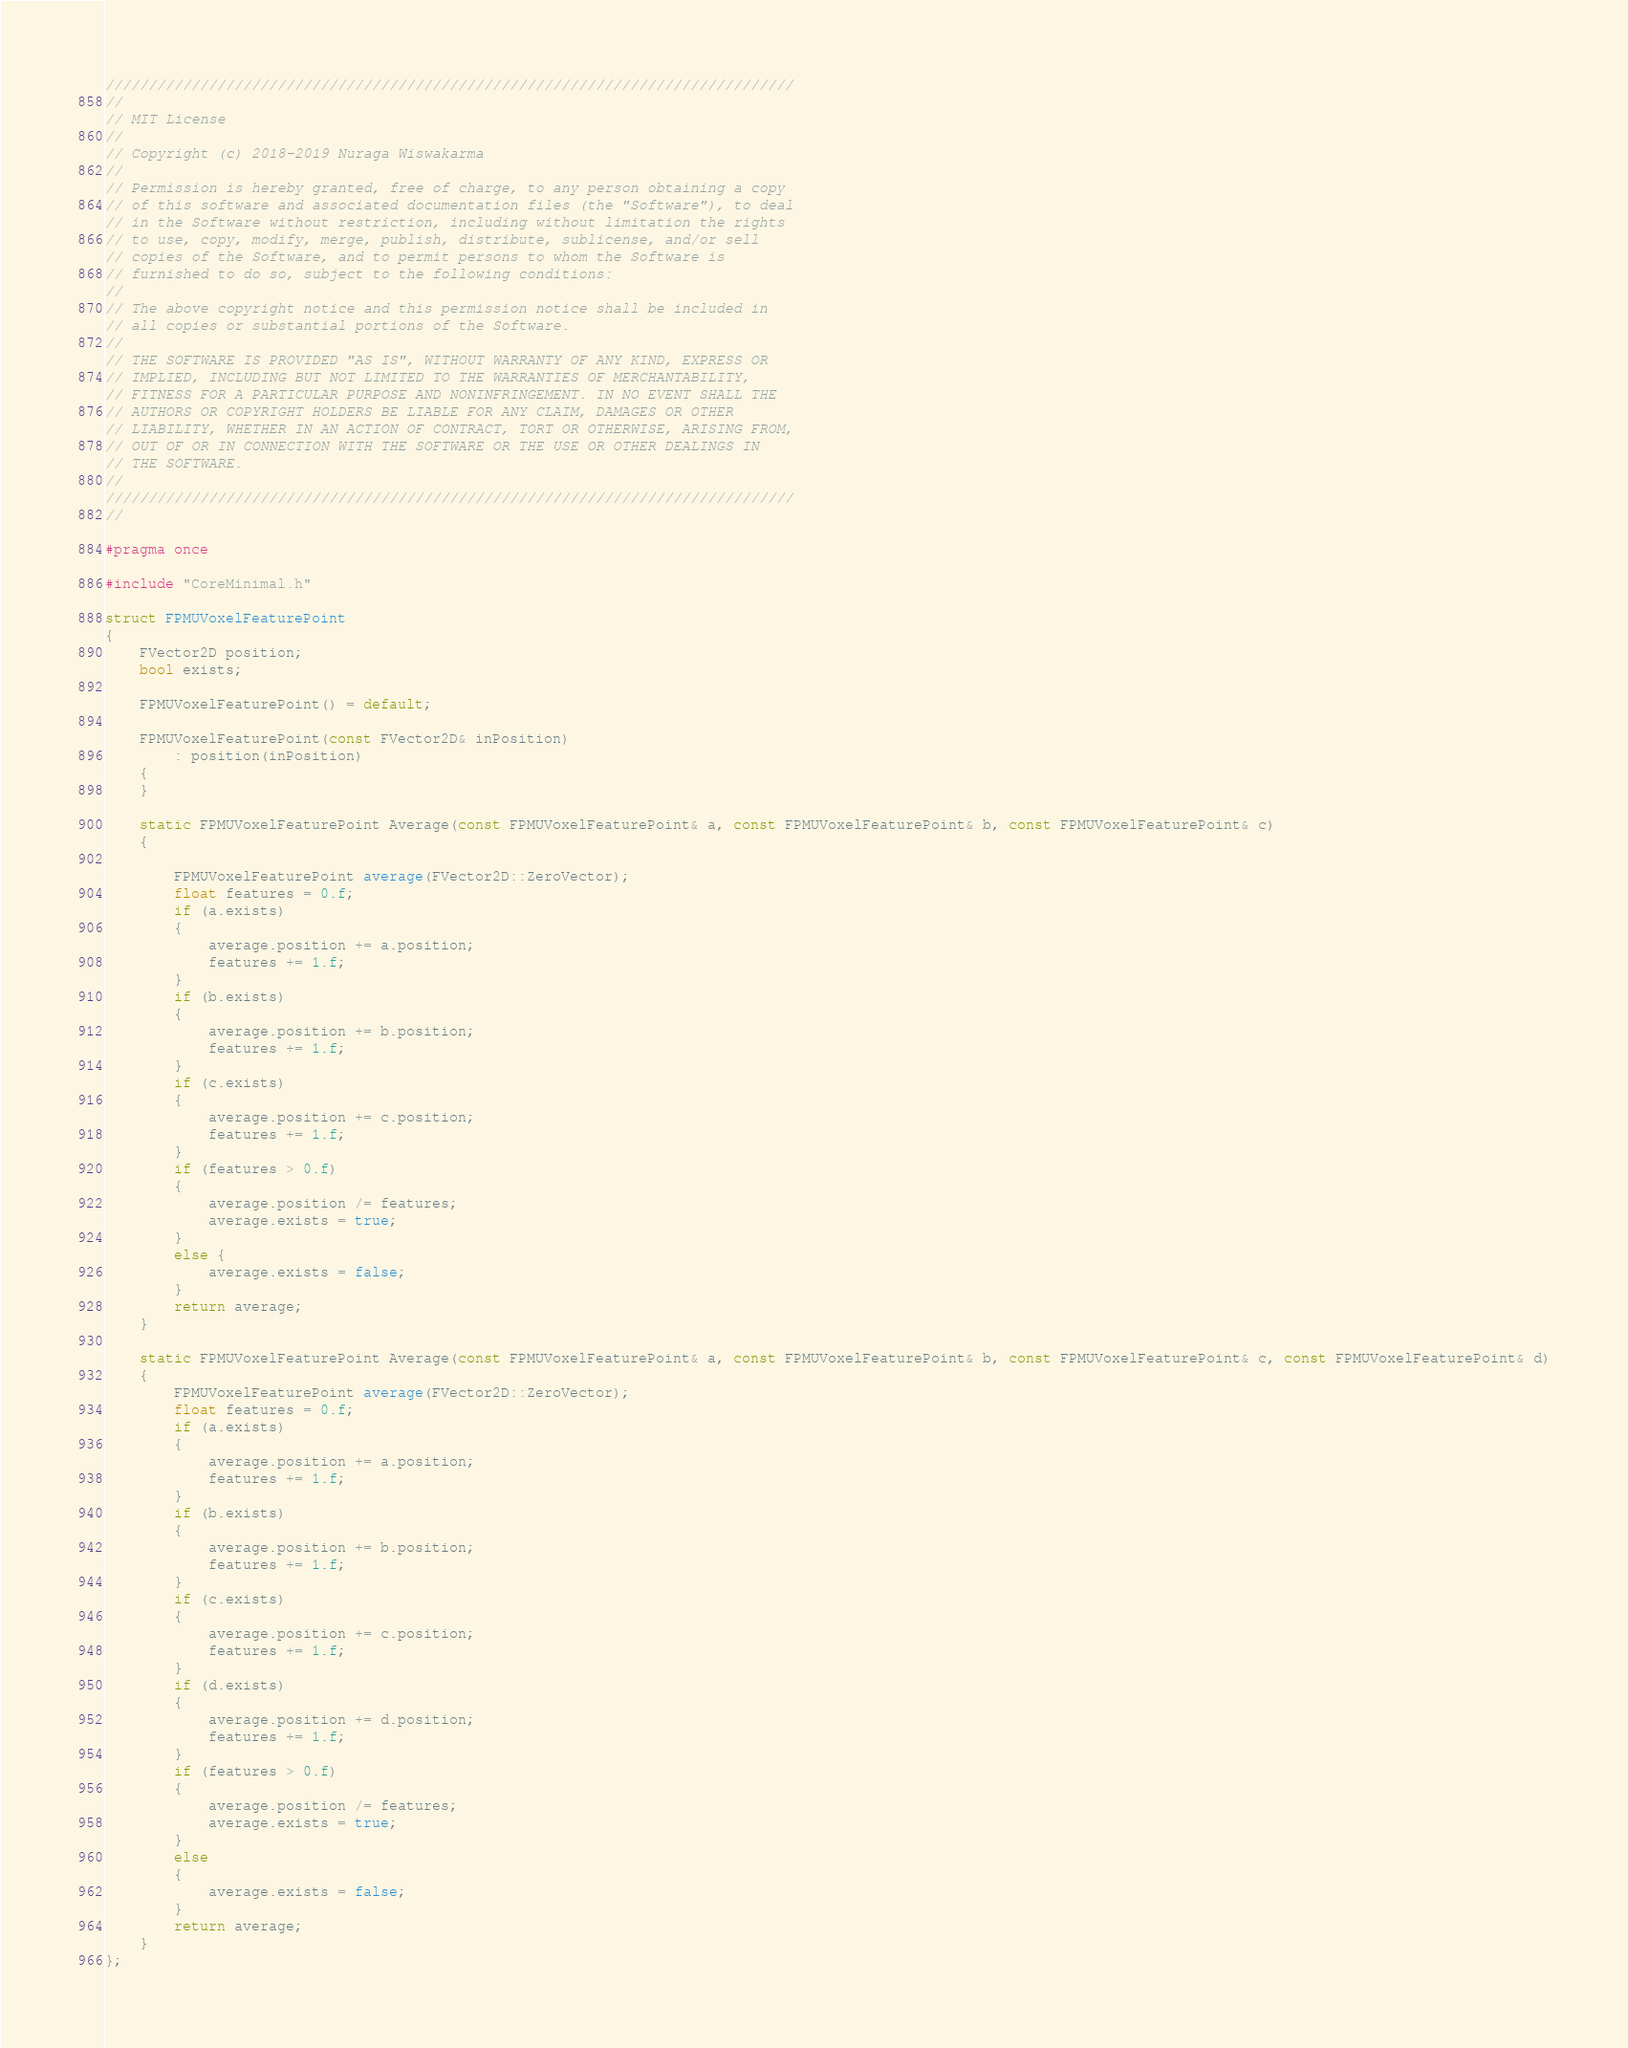<code> <loc_0><loc_0><loc_500><loc_500><_C_>////////////////////////////////////////////////////////////////////////////////
//
// MIT License
// 
// Copyright (c) 2018-2019 Nuraga Wiswakarma
// 
// Permission is hereby granted, free of charge, to any person obtaining a copy
// of this software and associated documentation files (the "Software"), to deal
// in the Software without restriction, including without limitation the rights
// to use, copy, modify, merge, publish, distribute, sublicense, and/or sell
// copies of the Software, and to permit persons to whom the Software is
// furnished to do so, subject to the following conditions:
// 
// The above copyright notice and this permission notice shall be included in
// all copies or substantial portions of the Software.
// 
// THE SOFTWARE IS PROVIDED "AS IS", WITHOUT WARRANTY OF ANY KIND, EXPRESS OR
// IMPLIED, INCLUDING BUT NOT LIMITED TO THE WARRANTIES OF MERCHANTABILITY,
// FITNESS FOR A PARTICULAR PURPOSE AND NONINFRINGEMENT. IN NO EVENT SHALL THE
// AUTHORS OR COPYRIGHT HOLDERS BE LIABLE FOR ANY CLAIM, DAMAGES OR OTHER
// LIABILITY, WHETHER IN AN ACTION OF CONTRACT, TORT OR OTHERWISE, ARISING FROM,
// OUT OF OR IN CONNECTION WITH THE SOFTWARE OR THE USE OR OTHER DEALINGS IN
// THE SOFTWARE.
//
////////////////////////////////////////////////////////////////////////////////
// 

#pragma once

#include "CoreMinimal.h"

struct FPMUVoxelFeaturePoint
{
	FVector2D position;
	bool exists;

    FPMUVoxelFeaturePoint() = default;

    FPMUVoxelFeaturePoint(const FVector2D& inPosition)
        : position(inPosition)
    {
    }

	static FPMUVoxelFeaturePoint Average(const FPMUVoxelFeaturePoint& a, const FPMUVoxelFeaturePoint& b, const FPMUVoxelFeaturePoint& c)
    {
		
		FPMUVoxelFeaturePoint average(FVector2D::ZeroVector);
		float features = 0.f;
		if (a.exists)
        {
			average.position += a.position;
			features += 1.f;
		}
		if (b.exists)
        {
			average.position += b.position;
			features += 1.f;
		}
		if (c.exists)
        {
			average.position += c.position;
			features += 1.f;
		}
		if (features > 0.f)
        {
			average.position /= features;
			average.exists = true;
		}
		else {
			average.exists = false;
		}
		return average;
	}

	static FPMUVoxelFeaturePoint Average(const FPMUVoxelFeaturePoint& a, const FPMUVoxelFeaturePoint& b, const FPMUVoxelFeaturePoint& c, const FPMUVoxelFeaturePoint& d)
    {
		FPMUVoxelFeaturePoint average(FVector2D::ZeroVector);
		float features = 0.f;
		if (a.exists)
        {
			average.position += a.position;
			features += 1.f;
		}
		if (b.exists)
        {
			average.position += b.position;
			features += 1.f;
		}
		if (c.exists)
        {
			average.position += c.position;
			features += 1.f;
		}
		if (d.exists)
        {
			average.position += d.position;
			features += 1.f;
		}
		if (features > 0.f)
        {
			average.position /= features;
			average.exists = true;
		}
		else
        {
			average.exists = false;
		}
		return average;
	}
};
</code> 